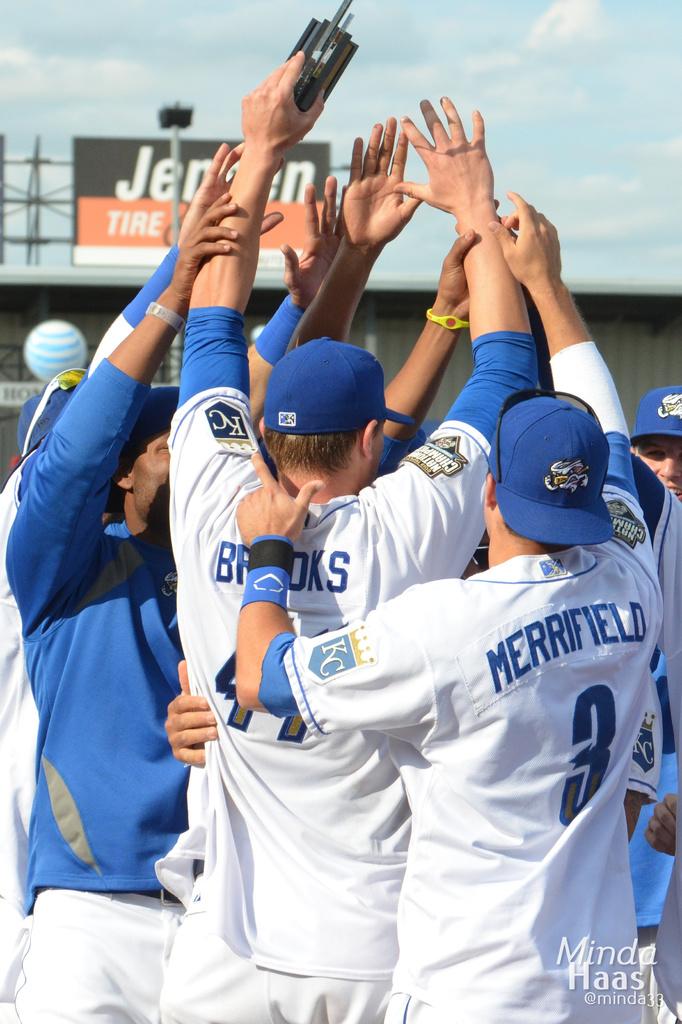What number is merrifield?
Your response must be concise. 3. What name is the player merrifield is touching?
Keep it short and to the point. Brooks. 